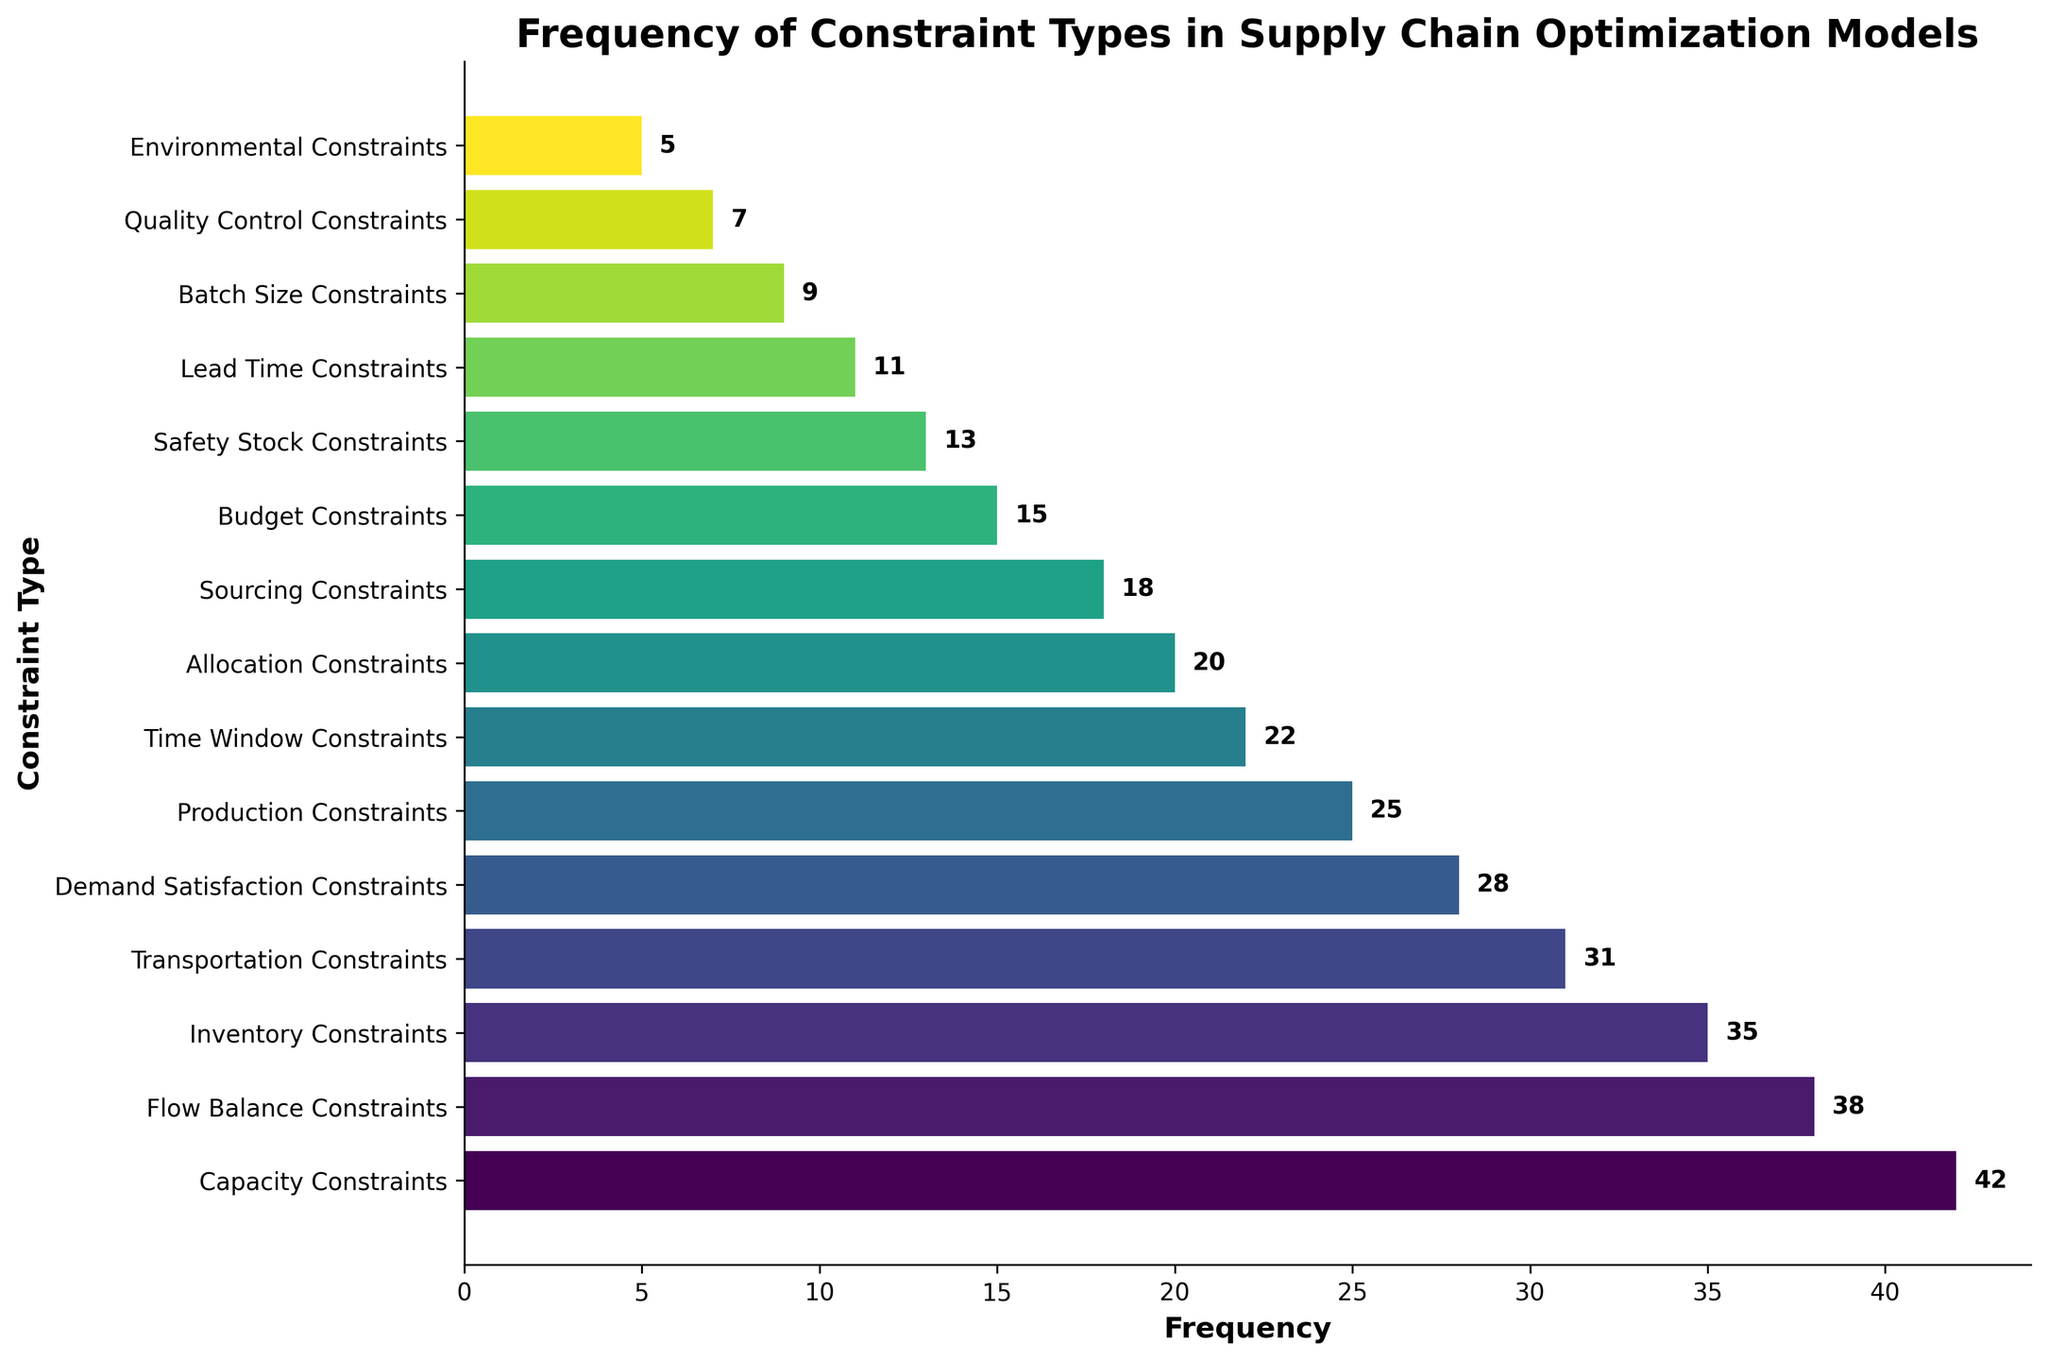Which constraint type has the highest frequency? The bar chart shows the frequencies of different constraint types. The highest bar corresponds to Capacity Constraints.
Answer: Capacity Constraints Which constraint type has the lowest frequency? The figure shows the frequencies of various constraint types. The shortest bar corresponds to Environmental Constraints.
Answer: Environmental Constraints What is the total frequency of the top three constraint types? The top three constraint types based on frequency are Capacity Constraints (42), Flow Balance Constraints (38), and Inventory Constraints (35). Summing them up: 42 + 38 + 35 = 115.
Answer: 115 Which constraint types have a frequency greater than 30 but less than 40? From the bar chart, the constraints within this range are Flow Balance Constraints (38), Inventory Constraints (35), and Transportation Constraints (31).
Answer: Flow Balance Constraints, Inventory Constraints, Transportation Constraints What is the average frequency of Production Constraints, Time Window Constraints, and Allocation Constraints? The frequencies are Production Constraints (25), Time Window Constraints (22), and Allocation Constraints (20). The average is (25 + 22 + 20) / 3 = 67 / 3 = 22.33.
Answer: 22.33 How much more frequent are Capacity Constraints compared to Demand Satisfaction Constraints? Capacity Constraints have a frequency of 42 and Demand Satisfaction Constraints have 28. The difference is 42 - 28 = 14.
Answer: 14 Which constraint type is ranked fifth in frequency? Sorting the frequencies in descending order, the fifth is Demand Satisfaction Constraints with a frequency of 28.
Answer: Demand Satisfaction Constraints How many constraint types have a frequency above the median value? There are 15 constraint types, so the median will be the 8th value when sorted. The median frequency is 20 (Allocation Constraints). The number of constraint types above this frequency is 7.
Answer: 7 What is the combined frequency of Budget Constraints, Safety Stock Constraints, Lead Time Constraints, and Batch Size Constraints? The frequencies are Budget Constraints (15), Safety Stock Constraints (13), Lead Time Constraints (11), and Batch Size Constraints (9). Summing them gives 15 + 13 + 11 + 9 = 48.
Answer: 48 Which constraint type is represented by the bar colored with the darkest shade? The color gradient used in the figure suggests that darker shades are associated with higher frequencies. The darkest shade corresponds to Capacity Constraints with a frequency of 42.
Answer: Capacity Constraints 